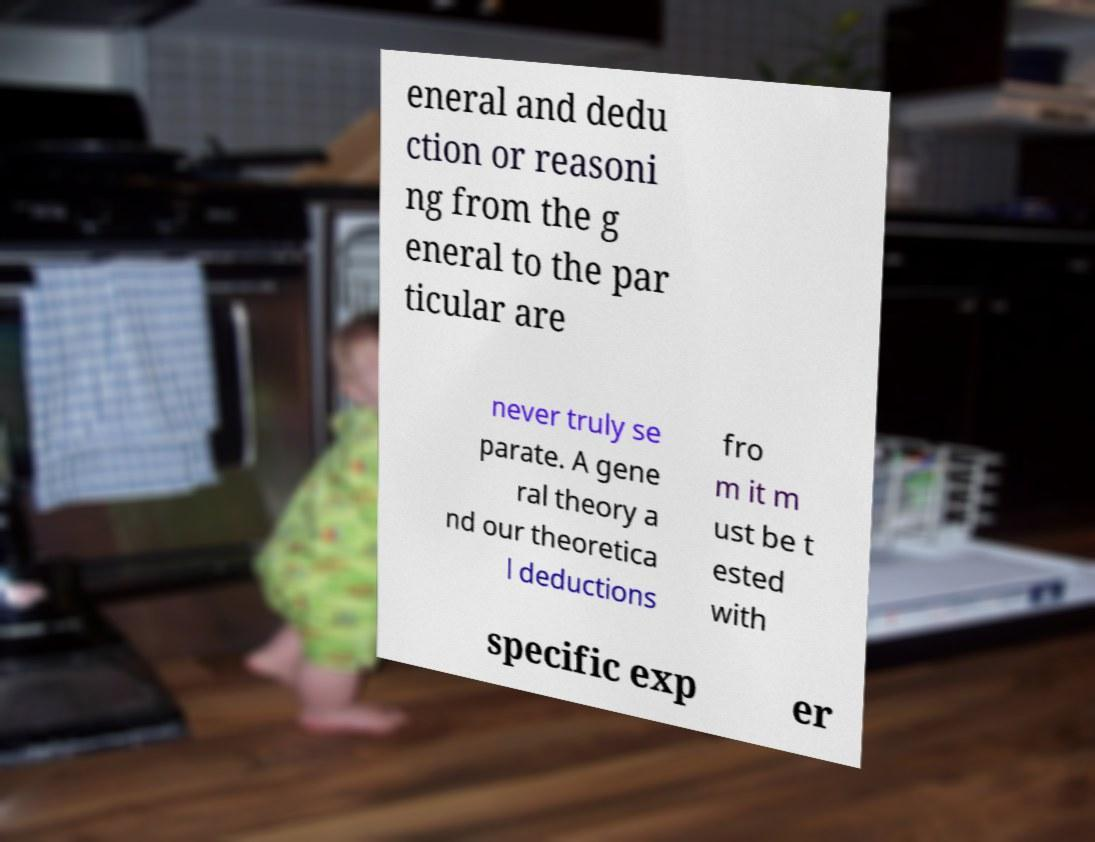There's text embedded in this image that I need extracted. Can you transcribe it verbatim? eneral and dedu ction or reasoni ng from the g eneral to the par ticular are never truly se parate. A gene ral theory a nd our theoretica l deductions fro m it m ust be t ested with specific exp er 